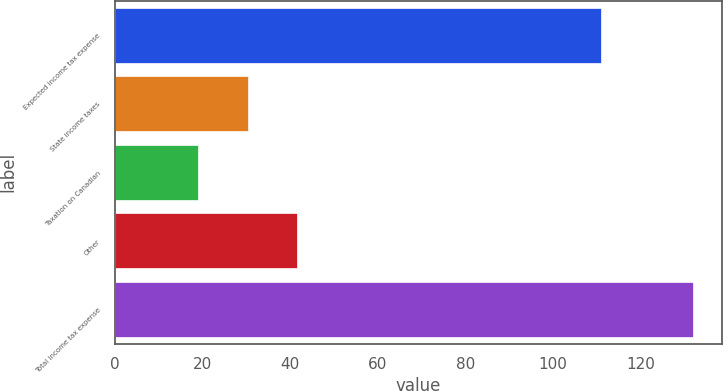Convert chart to OTSL. <chart><loc_0><loc_0><loc_500><loc_500><bar_chart><fcel>Expected income tax expense<fcel>State income taxes<fcel>Taxation on Canadian<fcel>Other<fcel>Total income tax expense<nl><fcel>111<fcel>30.3<fcel>19<fcel>41.6<fcel>132<nl></chart> 